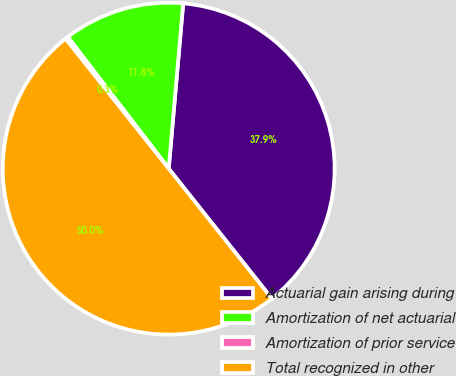Convert chart. <chart><loc_0><loc_0><loc_500><loc_500><pie_chart><fcel>Actuarial gain arising during<fcel>Amortization of net actuarial<fcel>Amortization of prior service<fcel>Total recognized in other<nl><fcel>37.93%<fcel>11.8%<fcel>0.27%<fcel>50.0%<nl></chart> 